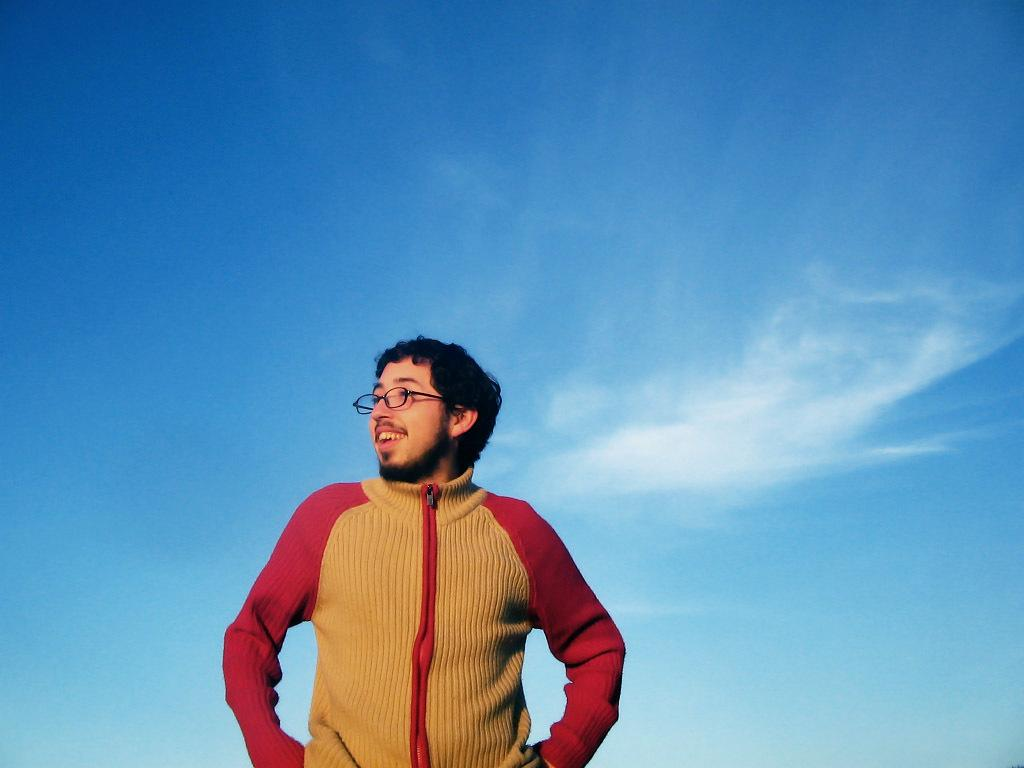What is the main subject of the image? The main subject of the image is a man. What is the man doing in the image? The man is standing in the image. Can you describe the man's appearance? The man is wearing spectacles and a red and yellow color jacket. He is also smiling. What can be seen in the background of the image? There is a sky visible in the background of the image, with clouds present. What type of plastic is used to make the sugar in the image? There is no plastic or sugar present in the image; it features a man standing and smiling. 